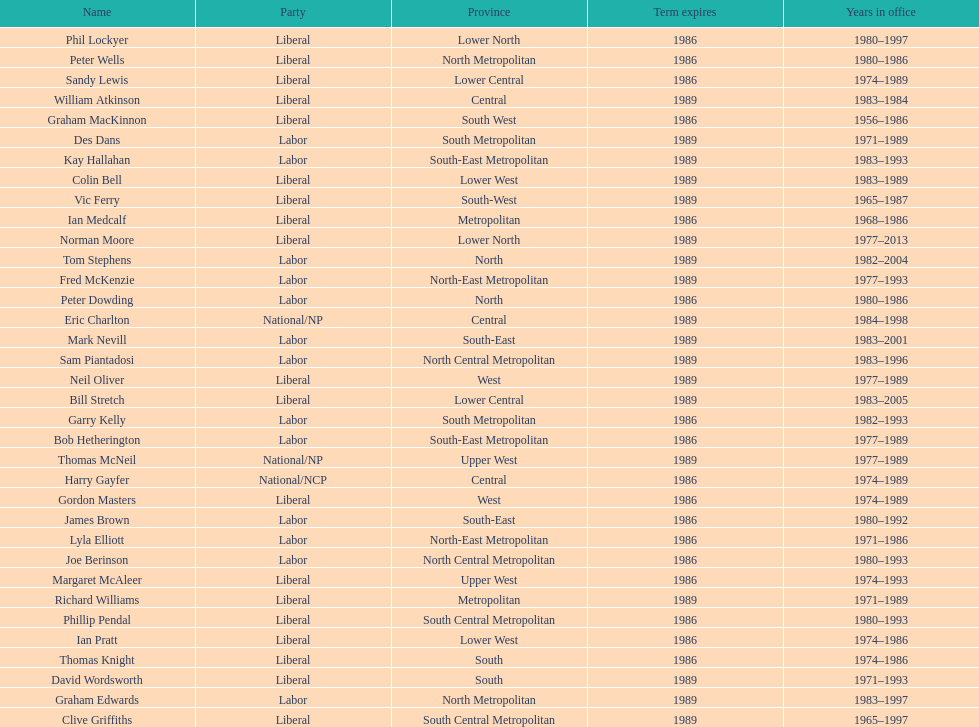Hame the last member listed whose last name begins with "p". Ian Pratt. 